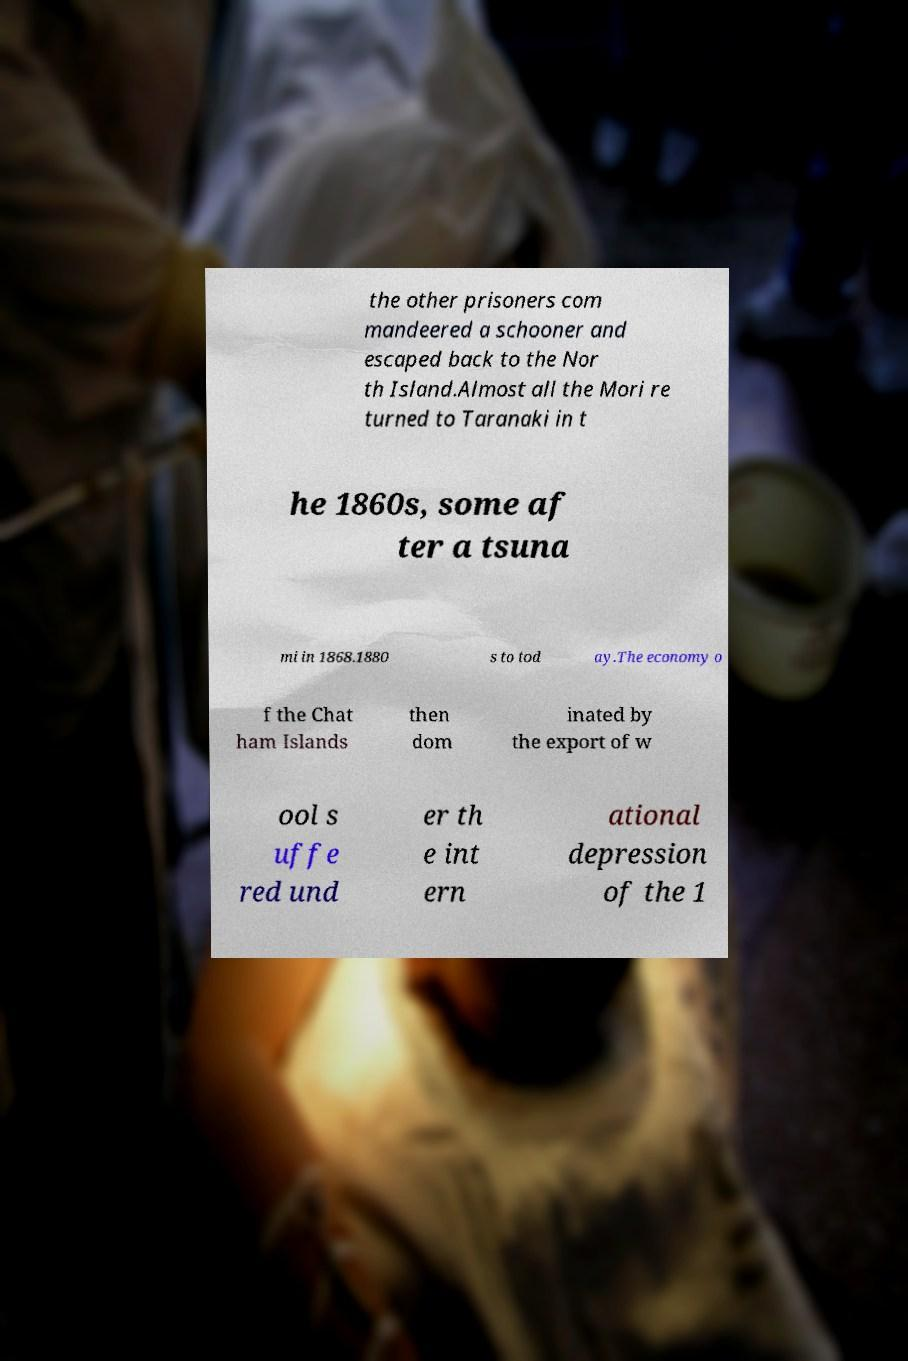For documentation purposes, I need the text within this image transcribed. Could you provide that? the other prisoners com mandeered a schooner and escaped back to the Nor th Island.Almost all the Mori re turned to Taranaki in t he 1860s, some af ter a tsuna mi in 1868.1880 s to tod ay.The economy o f the Chat ham Islands then dom inated by the export of w ool s uffe red und er th e int ern ational depression of the 1 